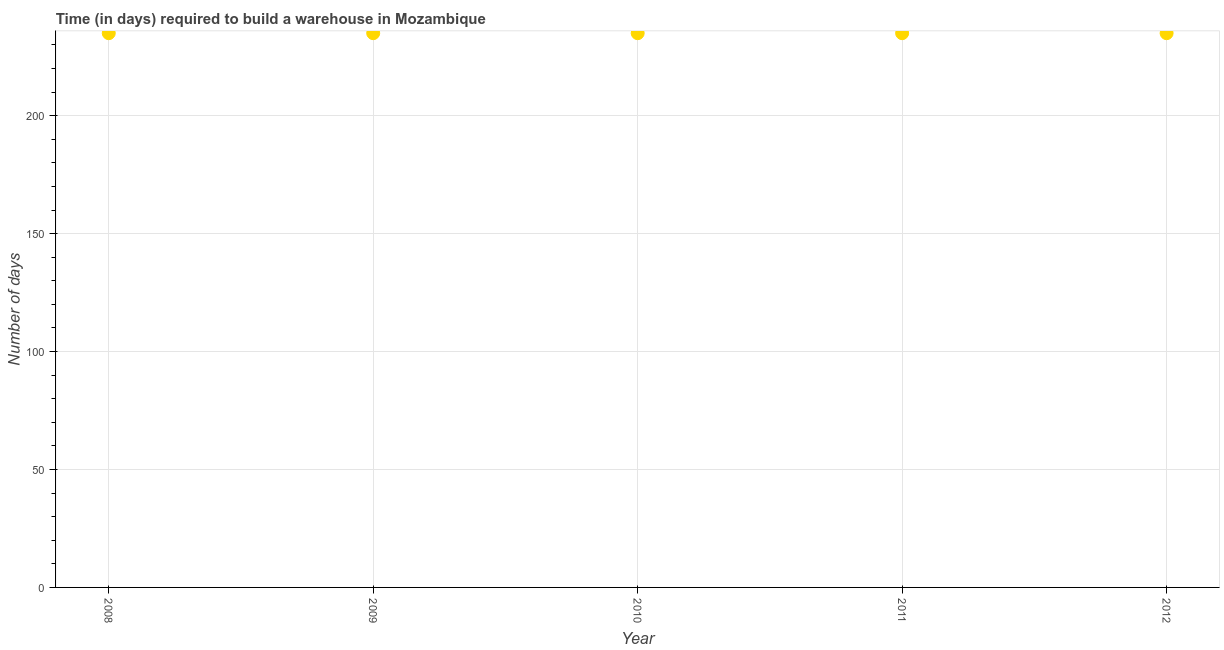What is the time required to build a warehouse in 2012?
Ensure brevity in your answer.  235. Across all years, what is the maximum time required to build a warehouse?
Your answer should be very brief. 235. Across all years, what is the minimum time required to build a warehouse?
Ensure brevity in your answer.  235. In which year was the time required to build a warehouse maximum?
Ensure brevity in your answer.  2008. In which year was the time required to build a warehouse minimum?
Your answer should be compact. 2008. What is the sum of the time required to build a warehouse?
Make the answer very short. 1175. What is the average time required to build a warehouse per year?
Give a very brief answer. 235. What is the median time required to build a warehouse?
Your answer should be compact. 235. Do a majority of the years between 2009 and 2012 (inclusive) have time required to build a warehouse greater than 10 days?
Your response must be concise. Yes. What is the ratio of the time required to build a warehouse in 2008 to that in 2009?
Make the answer very short. 1. What is the difference between the highest and the second highest time required to build a warehouse?
Provide a succinct answer. 0. Is the sum of the time required to build a warehouse in 2010 and 2011 greater than the maximum time required to build a warehouse across all years?
Ensure brevity in your answer.  Yes. In how many years, is the time required to build a warehouse greater than the average time required to build a warehouse taken over all years?
Ensure brevity in your answer.  0. Does the time required to build a warehouse monotonically increase over the years?
Offer a terse response. No. How many dotlines are there?
Your answer should be very brief. 1. How many years are there in the graph?
Your answer should be very brief. 5. Are the values on the major ticks of Y-axis written in scientific E-notation?
Your answer should be very brief. No. Does the graph contain any zero values?
Offer a very short reply. No. What is the title of the graph?
Provide a succinct answer. Time (in days) required to build a warehouse in Mozambique. What is the label or title of the X-axis?
Give a very brief answer. Year. What is the label or title of the Y-axis?
Give a very brief answer. Number of days. What is the Number of days in 2008?
Offer a very short reply. 235. What is the Number of days in 2009?
Your answer should be very brief. 235. What is the Number of days in 2010?
Give a very brief answer. 235. What is the Number of days in 2011?
Your answer should be very brief. 235. What is the Number of days in 2012?
Your response must be concise. 235. What is the difference between the Number of days in 2008 and 2009?
Your answer should be very brief. 0. What is the difference between the Number of days in 2008 and 2010?
Your answer should be compact. 0. What is the difference between the Number of days in 2008 and 2011?
Your response must be concise. 0. What is the difference between the Number of days in 2008 and 2012?
Make the answer very short. 0. What is the ratio of the Number of days in 2008 to that in 2009?
Ensure brevity in your answer.  1. What is the ratio of the Number of days in 2008 to that in 2010?
Offer a terse response. 1. What is the ratio of the Number of days in 2008 to that in 2011?
Offer a very short reply. 1. What is the ratio of the Number of days in 2009 to that in 2010?
Ensure brevity in your answer.  1. What is the ratio of the Number of days in 2009 to that in 2012?
Your response must be concise. 1. What is the ratio of the Number of days in 2010 to that in 2012?
Your response must be concise. 1. 